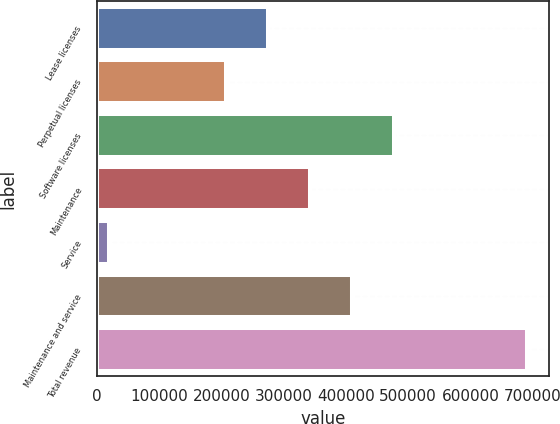Convert chart. <chart><loc_0><loc_0><loc_500><loc_500><bar_chart><fcel>Lease licenses<fcel>Perpetual licenses<fcel>Software licenses<fcel>Maintenance<fcel>Service<fcel>Maintenance and service<fcel>Total revenue<nl><fcel>275119<fcel>207876<fcel>476847<fcel>342361<fcel>19022<fcel>409604<fcel>691449<nl></chart> 